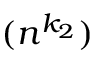<formula> <loc_0><loc_0><loc_500><loc_500>( n ^ { k _ { 2 } } )</formula> 